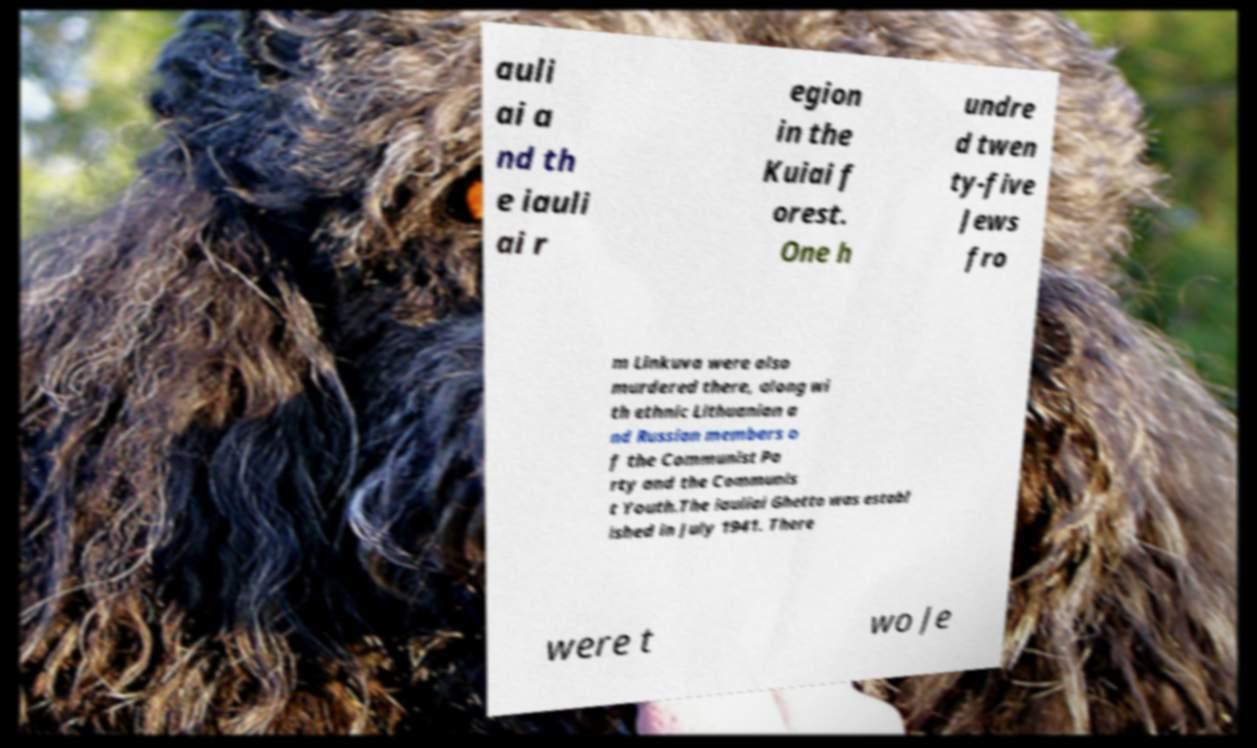For documentation purposes, I need the text within this image transcribed. Could you provide that? auli ai a nd th e iauli ai r egion in the Kuiai f orest. One h undre d twen ty-five Jews fro m Linkuva were also murdered there, along wi th ethnic Lithuanian a nd Russian members o f the Communist Pa rty and the Communis t Youth.The iauliai Ghetto was establ ished in July 1941. There were t wo Je 